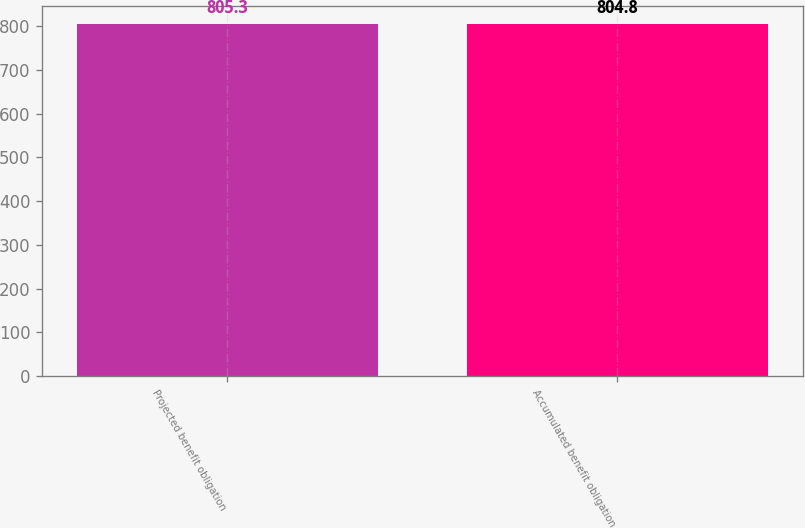Convert chart. <chart><loc_0><loc_0><loc_500><loc_500><bar_chart><fcel>Projected benefit obligation<fcel>Accumulated benefit obligation<nl><fcel>805.3<fcel>804.8<nl></chart> 